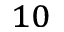<formula> <loc_0><loc_0><loc_500><loc_500>_ { 1 0 }</formula> 